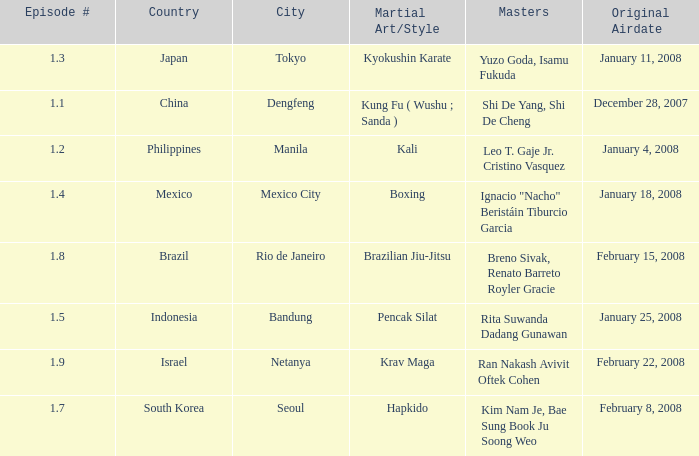How many masters fought using a boxing style? 1.0. 